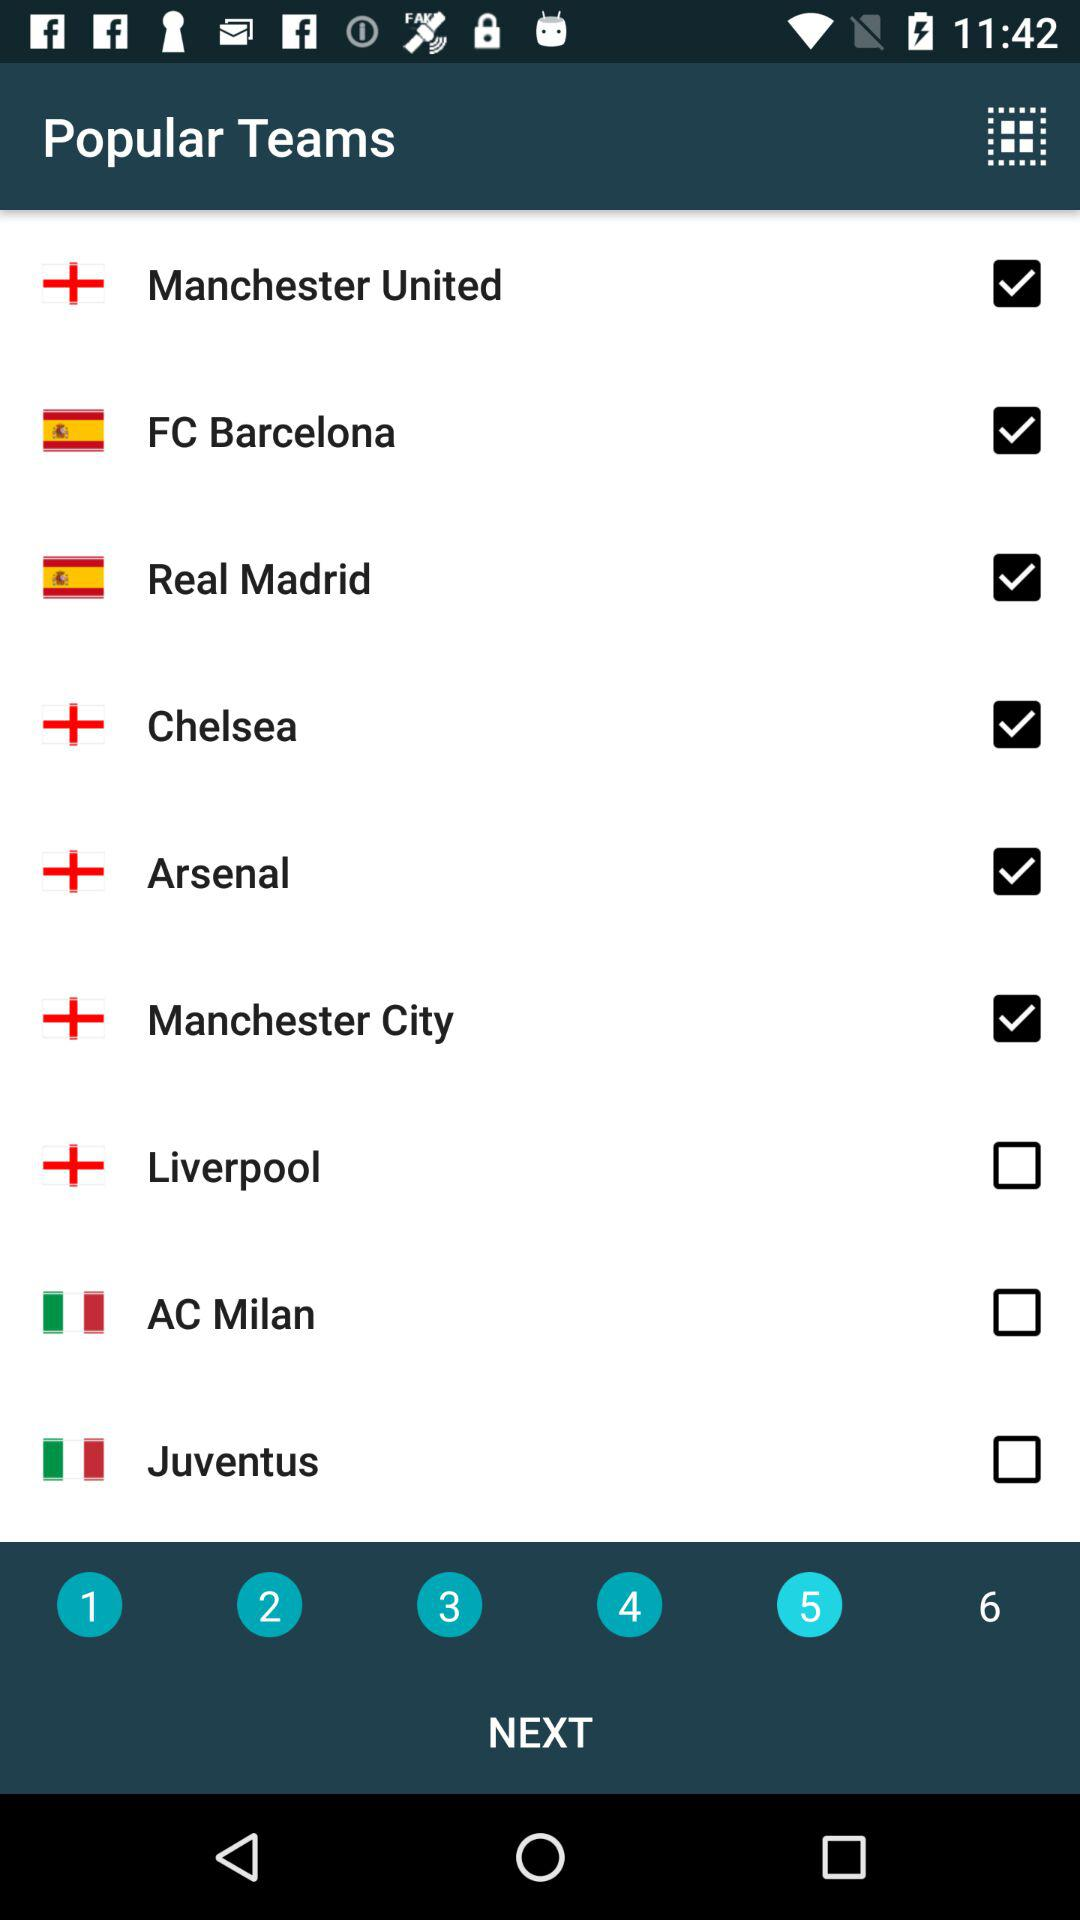Which page number is currently displayed? The currently displayed page number is 5. 